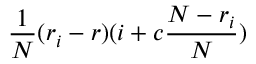<formula> <loc_0><loc_0><loc_500><loc_500>\frac { 1 } { N } ( r _ { i } - r ) ( i + c \frac { N - r _ { i } } { N } )</formula> 